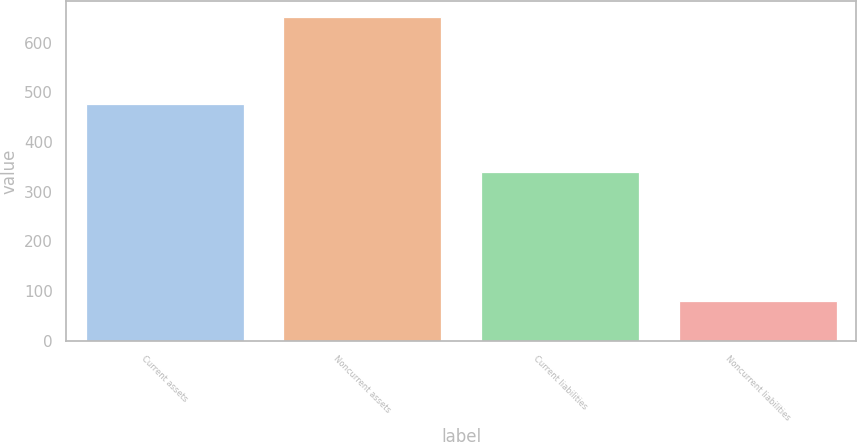<chart> <loc_0><loc_0><loc_500><loc_500><bar_chart><fcel>Current assets<fcel>Noncurrent assets<fcel>Current liabilities<fcel>Noncurrent liabilities<nl><fcel>476.9<fcel>651.4<fcel>340.1<fcel>80.2<nl></chart> 